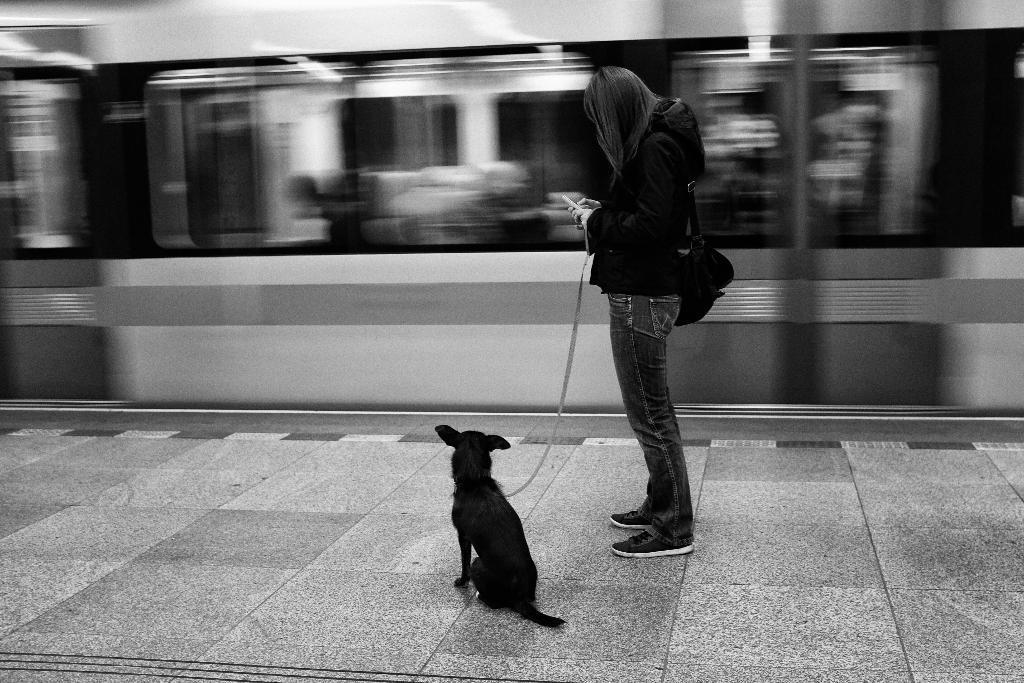How would you summarize this image in a sentence or two? a person is standing wearing a bag, holding the belt of a black dog on the platform. at the back a train is passing. the woman is wearing a black t shirt and a jeans. 